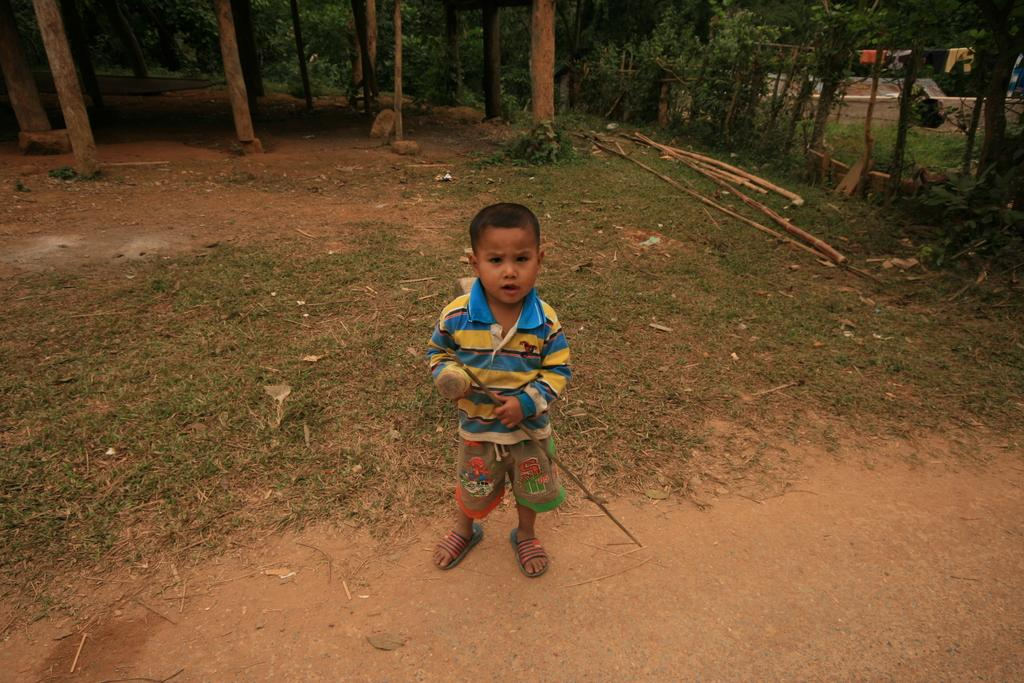What is the main subject in the center of the image? There is a boy in the center of the image. What is the boy holding in the image? The boy is holding a stick. What can be seen in the background of the image? There are trees, poles, logs, and clothes hanging on a rope in the background of the image. What type of throne is the boy sitting on in the image? There is no throne present in the image; the boy is standing and holding a stick. 